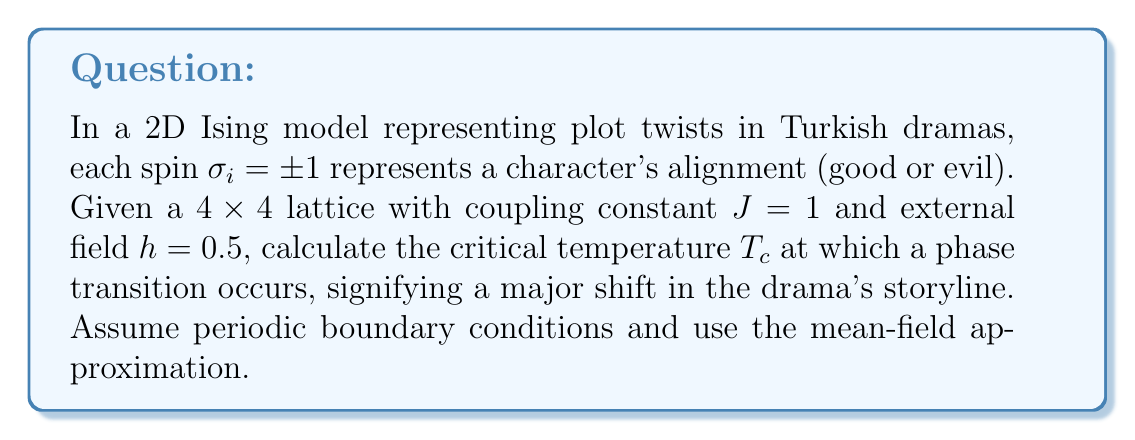Teach me how to tackle this problem. 1. In the mean-field approximation for a 2D Ising model, the critical temperature is given by:

   $$T_c = \frac{2zJ}{k_B}$$

   where $z$ is the coordination number, $J$ is the coupling constant, and $k_B$ is the Boltzmann constant.

2. For a 2D square lattice, $z = 4$ (each spin interacts with 4 nearest neighbors).

3. Given $J = 1$ and setting $k_B = 1$ for simplicity:

   $$T_c = \frac{2 \cdot 4 \cdot 1}{1} = 8$$

4. However, the presence of an external field $h$ modifies the critical temperature. In the mean-field approximation, the modified critical temperature $T_c'$ is given by:

   $$T_c' = T_c \left(1 + \frac{h^2}{2J^2z^2}\right)^{1/2}$$

5. Substituting the values:

   $$T_c' = 8 \left(1 + \frac{0.5^2}{2 \cdot 1^2 \cdot 4^2}\right)^{1/2}$$

6. Simplifying:

   $$T_c' = 8 \left(1 + \frac{0.25}{32}\right)^{1/2} = 8 \left(1 + \frac{1}{128}\right)^{1/2}$$

7. Calculate the final result:

   $$T_c' \approx 8.0313$$

This critical temperature represents the point at which a phase transition occurs in the Turkish drama's plot, signifying a major shift in character alignments and storyline.
Answer: $T_c' \approx 8.0313$ 